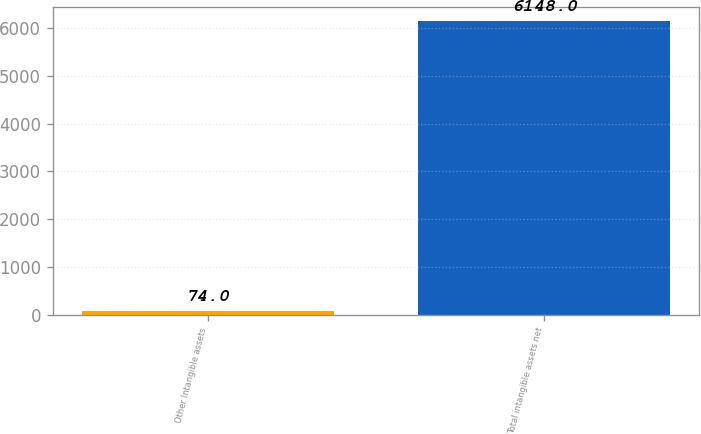Convert chart to OTSL. <chart><loc_0><loc_0><loc_500><loc_500><bar_chart><fcel>Other Intangible assets<fcel>Total intangible assets net<nl><fcel>74<fcel>6148<nl></chart> 